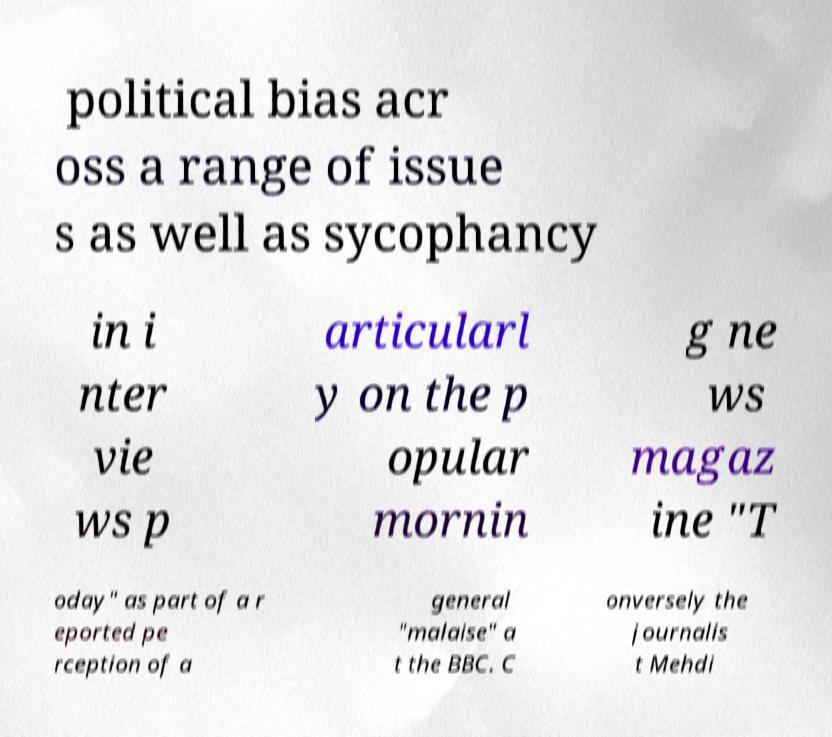Please identify and transcribe the text found in this image. political bias acr oss a range of issue s as well as sycophancy in i nter vie ws p articularl y on the p opular mornin g ne ws magaz ine "T oday" as part of a r eported pe rception of a general "malaise" a t the BBC. C onversely the journalis t Mehdi 